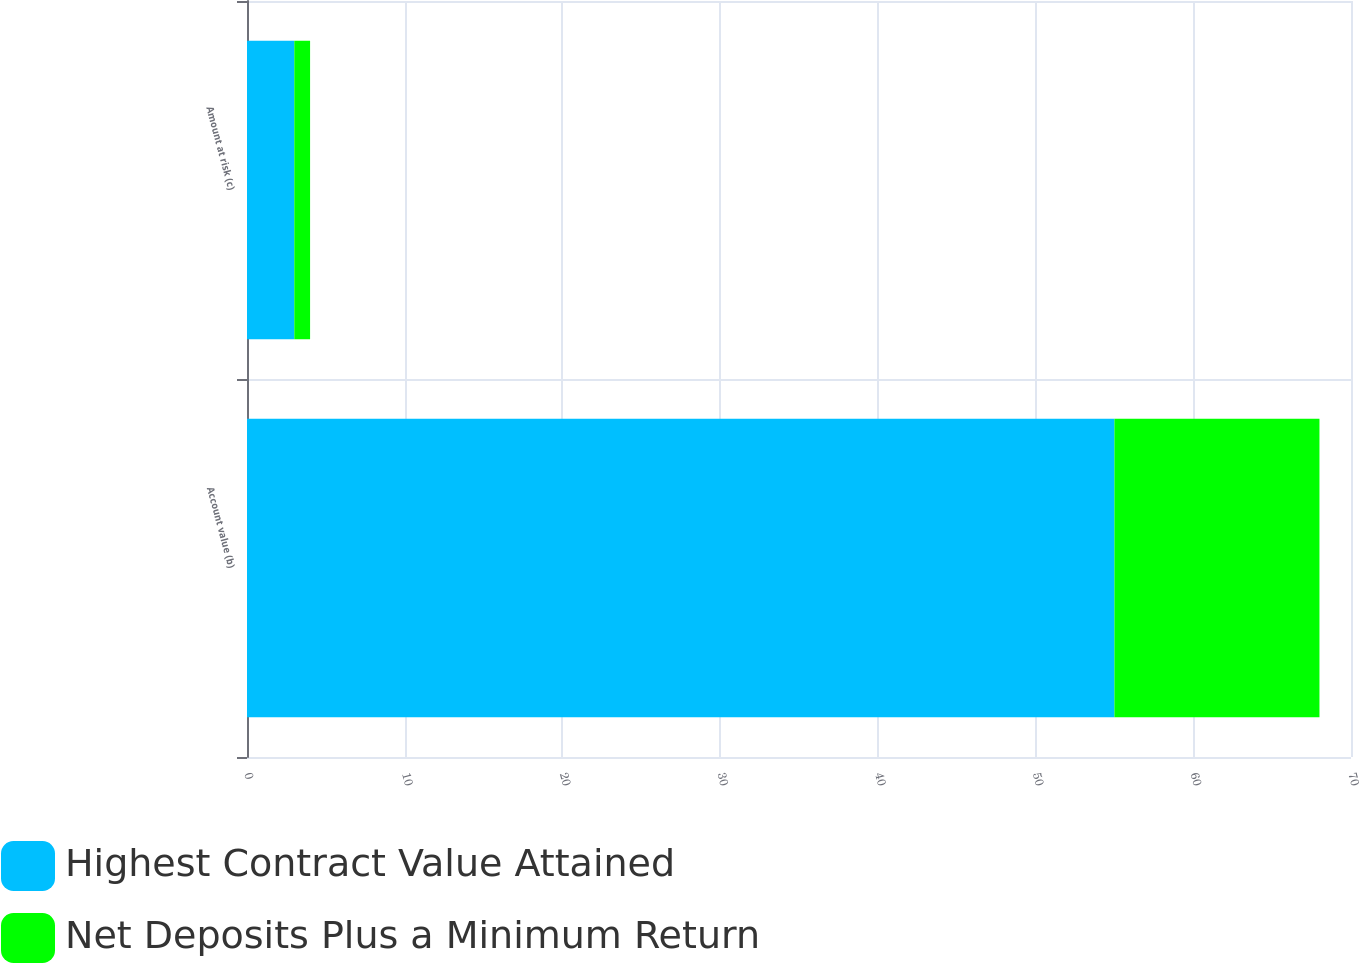<chart> <loc_0><loc_0><loc_500><loc_500><stacked_bar_chart><ecel><fcel>Account value (b)<fcel>Amount at risk (c)<nl><fcel>Highest Contract Value Attained<fcel>55<fcel>3<nl><fcel>Net Deposits Plus a Minimum Return<fcel>13<fcel>1<nl></chart> 